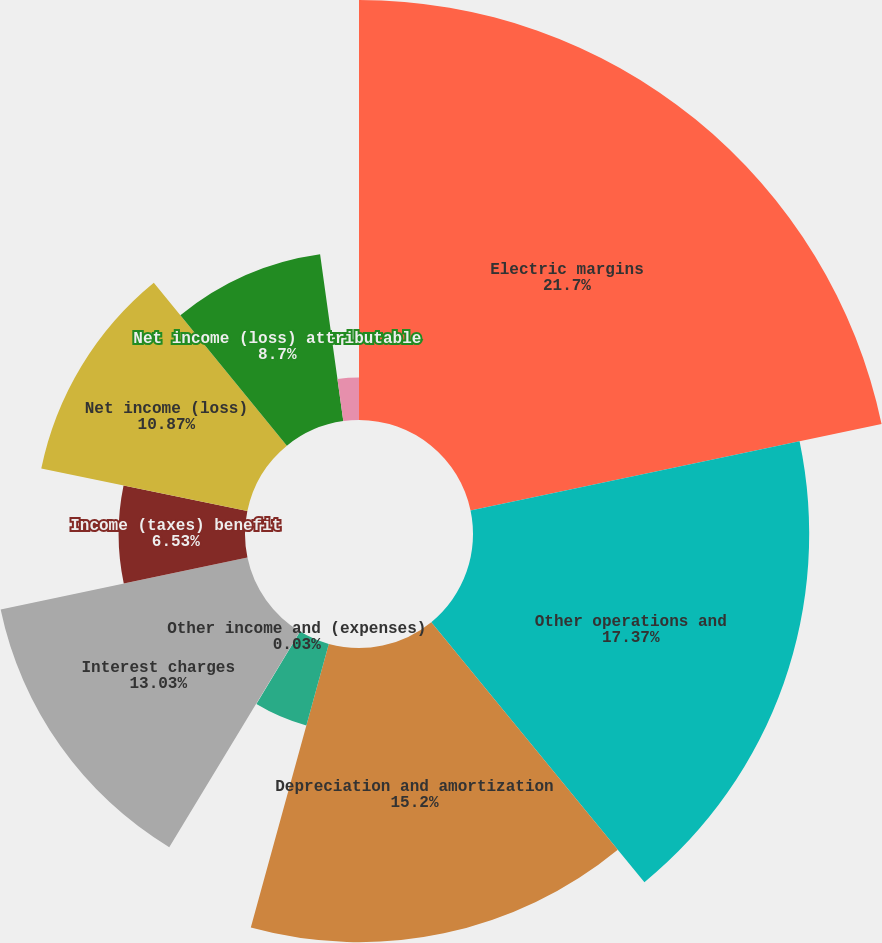Convert chart to OTSL. <chart><loc_0><loc_0><loc_500><loc_500><pie_chart><fcel>Electric margins<fcel>Other operations and<fcel>Depreciation and amortization<fcel>Taxes other than income taxes<fcel>Other income and (expenses)<fcel>Interest charges<fcel>Income (taxes) benefit<fcel>Net income (loss)<fcel>Net income (loss) attributable<fcel>Noncontrolling interest and<nl><fcel>21.7%<fcel>17.37%<fcel>15.2%<fcel>4.37%<fcel>0.03%<fcel>13.03%<fcel>6.53%<fcel>10.87%<fcel>8.7%<fcel>2.2%<nl></chart> 